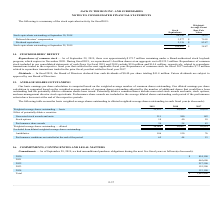According to Jack In The Box's financial document, How is the basic earnings per share calculation computed? Based on the weighted-average number of common shares outstanding. The document states: "basic earnings per share calculation is computed based on the weighted-average number of common shares outstanding. Our diluted earnings per share bas..." Also, What is the value of dilute weighted-average shares outstanding in 2019?  According to the financial document, 26,068 (in thousands). The relevant text states: "Weighted-average shares outstanding — diluted 26,068 28,807 30,914..." Also, When are performance share awards included in the average diluted shares outstanding each period? If the performance criteria have been met at the end of the respective periods. The document states: "he average diluted shares outstanding each period if the performance criteria have been met at the end of the respective periods...." Also, can you calculate: What is the average number of basic weighted-average shares outstanding from 2017-2019? To answer this question, I need to perform calculations using the financial data. The calculation is: (25,823+28,499+30,630)/3, which equals 28317.33 (in thousands). This is based on the information: "-average shares outstanding — basic 25,823 28,499 30,630 Weighted-average shares outstanding — basic 25,823 28,499 30,630 eighted-average shares outstanding — basic 25,823 28,499 30,630..." The key data points involved are: 25,823, 28,499, 30,630. Also, can you calculate: What is the difference in nonvested stock awards and units between 2018 and 2019? Based on the calculation: 240-211, the result is 29 (in thousands). This is based on the information: "Nonvested stock awards and units 211 240 182 Nonvested stock awards and units 211 240 182..." The key data points involved are: 211, 240. Also, can you calculate: What is the percentage constitution of performance share awards among the total diluted weighted-average shares outstanding in 2018? Based on the calculation: 28/28,807, the result is 0.1 (percentage). This is based on the information: "ghted-average shares outstanding — diluted 26,068 28,807 30,914 ghted-average shares outstanding — diluted 26,068 28,807 30,914..." The key data points involved are: 28, 28,807. 